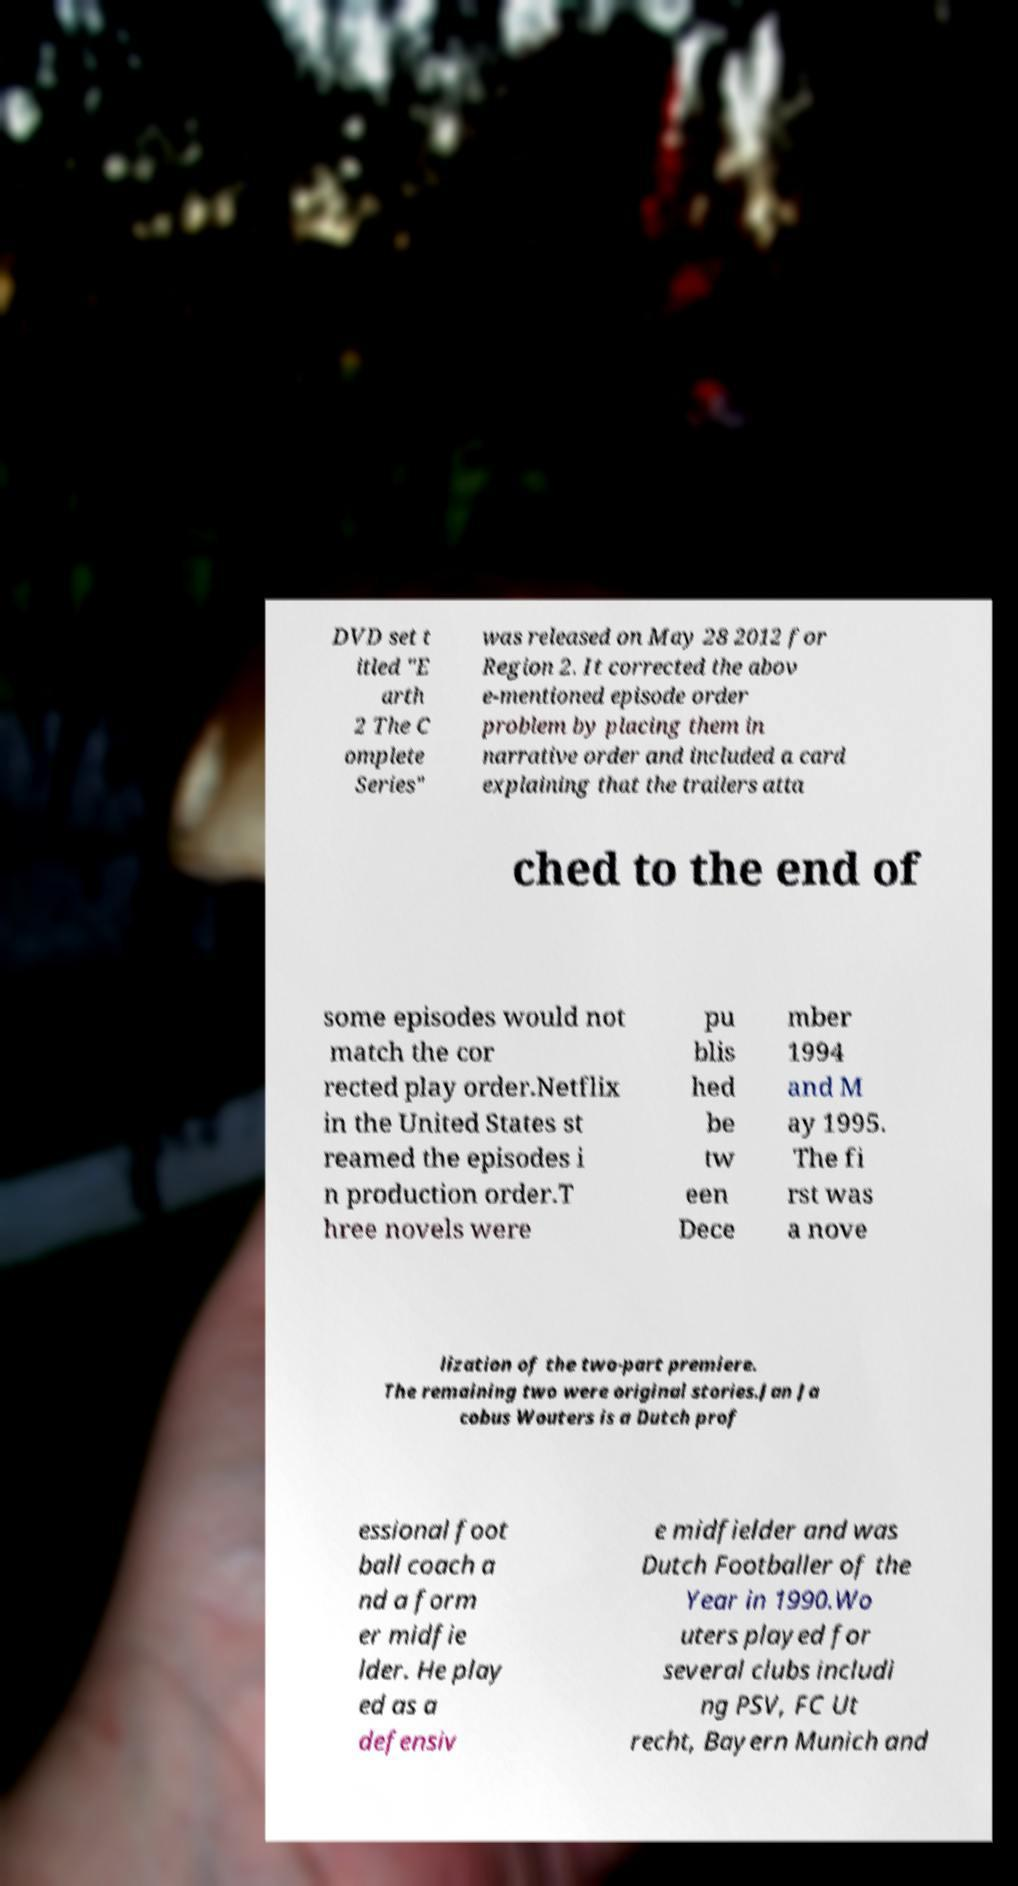I need the written content from this picture converted into text. Can you do that? DVD set t itled "E arth 2 The C omplete Series" was released on May 28 2012 for Region 2. It corrected the abov e-mentioned episode order problem by placing them in narrative order and included a card explaining that the trailers atta ched to the end of some episodes would not match the cor rected play order.Netflix in the United States st reamed the episodes i n production order.T hree novels were pu blis hed be tw een Dece mber 1994 and M ay 1995. The fi rst was a nove lization of the two-part premiere. The remaining two were original stories.Jan Ja cobus Wouters is a Dutch prof essional foot ball coach a nd a form er midfie lder. He play ed as a defensiv e midfielder and was Dutch Footballer of the Year in 1990.Wo uters played for several clubs includi ng PSV, FC Ut recht, Bayern Munich and 